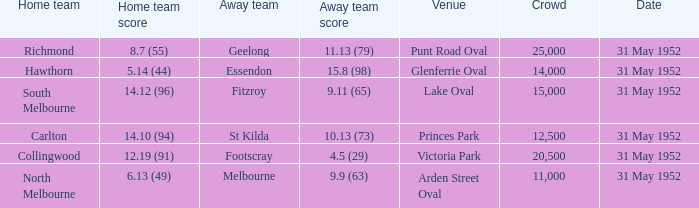When was the game when Footscray was the away team? 31 May 1952. 